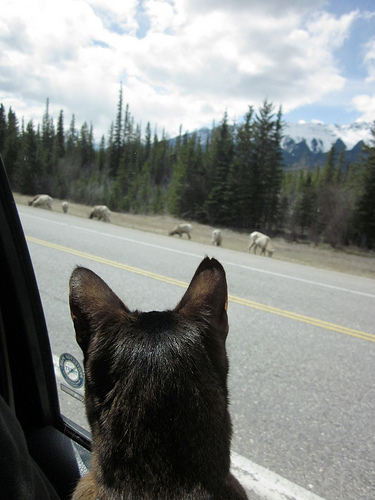<image>
Is there a sheep in the road? No. The sheep is not contained within the road. These objects have a different spatial relationship. Is there a cat in front of the sheep? Yes. The cat is positioned in front of the sheep, appearing closer to the camera viewpoint. 